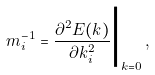Convert formula to latex. <formula><loc_0><loc_0><loc_500><loc_500>m _ { i } ^ { - 1 } = \frac { \partial ^ { 2 } E ( k ) } { \partial k _ { i } ^ { 2 } } \Big | _ { k = 0 } \, ,</formula> 